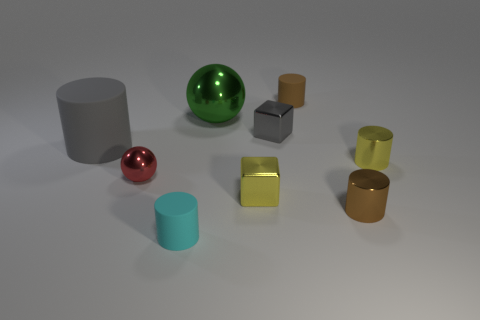Are there any other things that are the same color as the large shiny thing?
Provide a succinct answer. No. There is a yellow object left of the small metallic cylinder behind the tiny brown metallic cylinder; what is its material?
Your answer should be compact. Metal. The metal object that is the same color as the large cylinder is what shape?
Your answer should be compact. Cube. Is there a big thing made of the same material as the tiny red ball?
Give a very brief answer. Yes. Do the green ball and the small cube that is in front of the big gray rubber object have the same material?
Provide a succinct answer. Yes. There is a rubber object that is the same size as the brown rubber cylinder; what color is it?
Your answer should be compact. Cyan. What size is the rubber thing on the right side of the shiny block that is behind the red object?
Ensure brevity in your answer.  Small. Is the color of the big matte object the same as the small matte object behind the big metal ball?
Provide a succinct answer. No. Is the number of matte cylinders to the left of the cyan matte cylinder less than the number of cyan objects?
Your answer should be very brief. No. How many other things are there of the same size as the yellow metallic cylinder?
Offer a terse response. 6. 